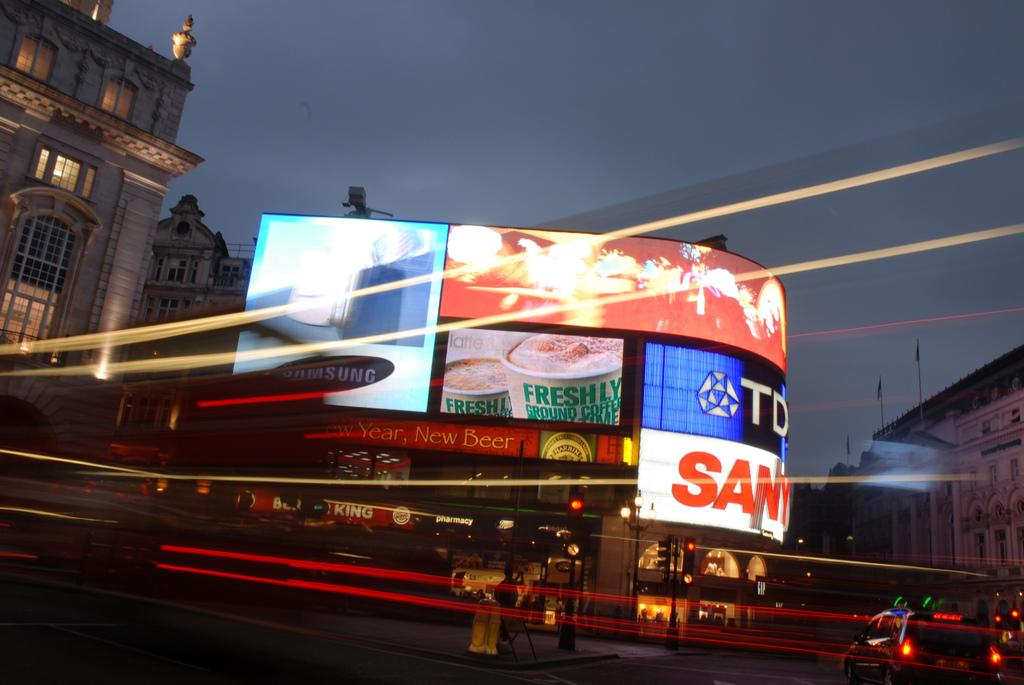<image>
Summarize the visual content of the image. Neon lit billboard signs are displayed on a side of a street at night and the letters TD can be seen. 